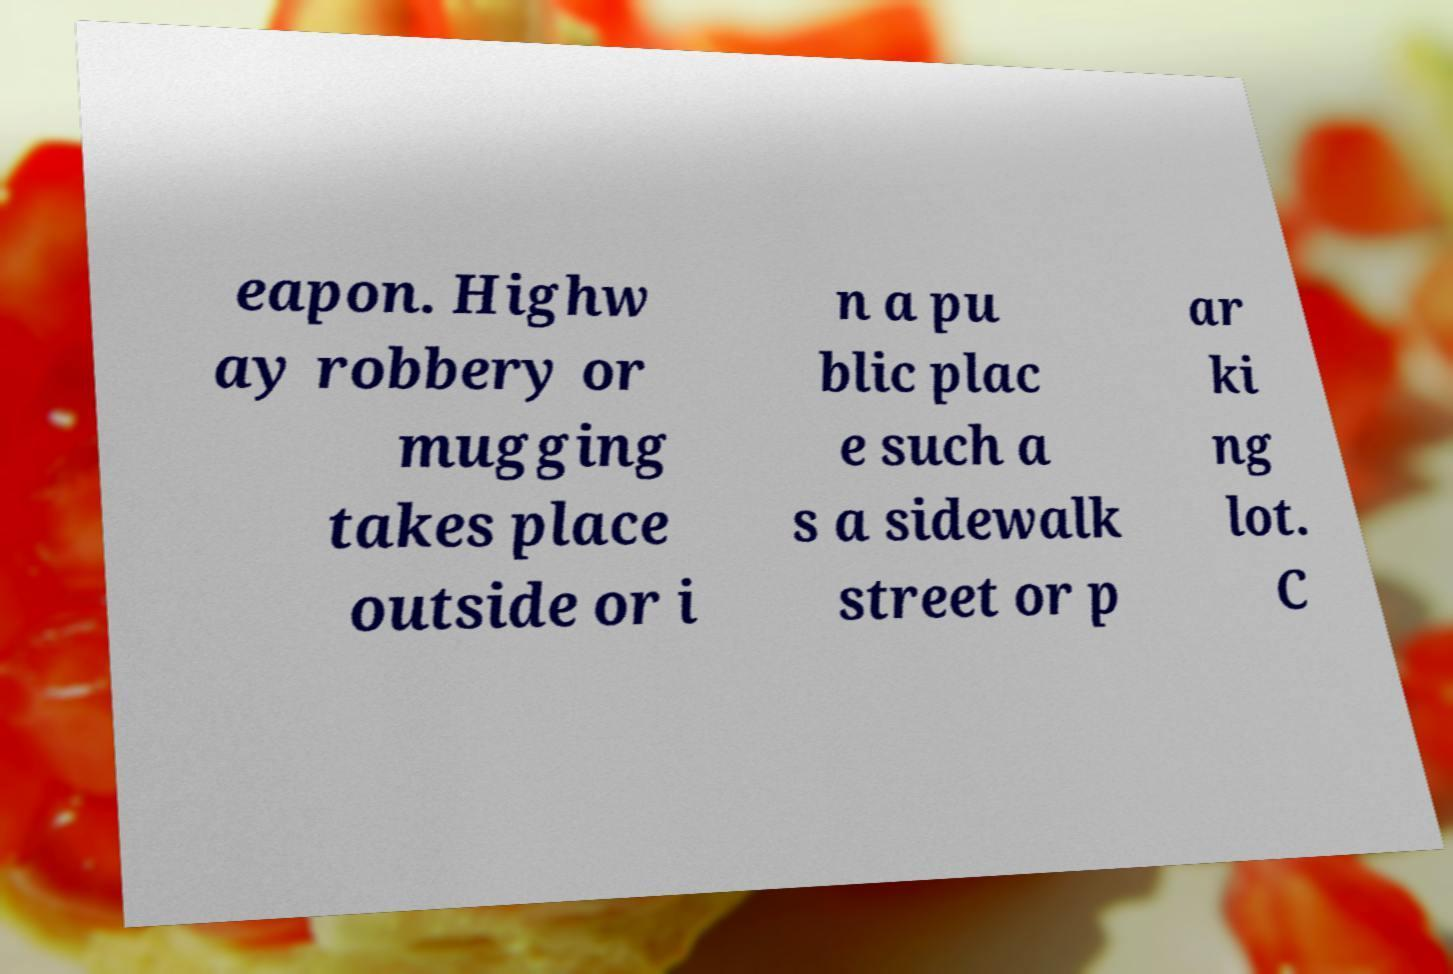Can you read and provide the text displayed in the image?This photo seems to have some interesting text. Can you extract and type it out for me? eapon. Highw ay robbery or mugging takes place outside or i n a pu blic plac e such a s a sidewalk street or p ar ki ng lot. C 